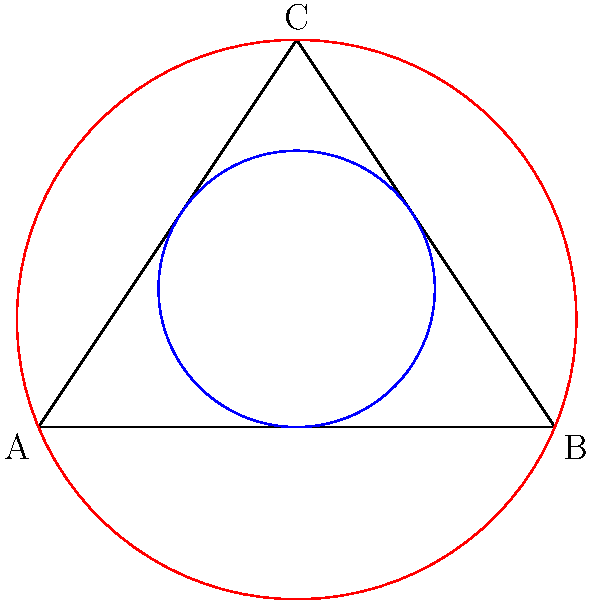In a mixed-gender sports competition, a triangular playing field is designed to represent balanced gender representation. The inscribed circle represents the core mixed-gender area, while the circumscribed circle represents the total field of play. If the radius of the inscribed circle is $r$ and the radius of the circumscribed circle is $R$, what is the ratio of $r$ to $R$ in terms of the semi-perimeter $s$ and the area $A$ of the triangle? To find the ratio of $r$ to $R$, we'll use the formulas for the radii of inscribed and circumscribed circles of a triangle:

1) For the inscribed circle: $r = \frac{A}{s}$, where $A$ is the area of the triangle and $s$ is the semi-perimeter.

2) For the circumscribed circle: $R = \frac{abc}{4A}$, where $a$, $b$, and $c$ are the side lengths of the triangle.

3) We can express $s$ in terms of $a$, $b$, and $c$: $s = \frac{a+b+c}{2}$

4) Now, let's set up the ratio:
   $\frac{r}{R} = \frac{A/s}{abc/(4A)}$

5) Simplify:
   $\frac{r}{R} = \frac{4A^2}{abcs}$

6) Recall that the area of a triangle can be expressed as $A = rs$ (area of a triangle = radius of inscribed circle * semi-perimeter)

7) Substitute $A = rs$ into our ratio:
   $\frac{r}{R} = \frac{4(rs)^2}{abcs} = \frac{4r^2s}{abc}$

8) Now, we have the ratio in terms of $r$, $s$, and the side lengths. To express it solely in terms of $s$ and $A$, we can use the formula for the area of a triangle: $A = \sqrt{s(s-a)(s-b)(s-c)}$

9) Square both sides: $A^2 = s(s-a)(s-b)(s-c)$

10) Divide both sides by $abc$: $\frac{A^2}{abc} = \frac{s(s-a)(s-b)(s-c)}{abc}$

11) The right side of this equation is equal to $\frac{r^2s}{abc}$ (from step 7)

12) Therefore, $\frac{r^2s}{abc} = \frac{A^2}{abc}$

13) Substitute this into our ratio from step 7:
    $\frac{r}{R} = \frac{4r^2s}{abc} = \frac{4A^2}{abc} = 4 \cdot \frac{A^2}{abc}$

Thus, we have derived the ratio of $r$ to $R$ in terms of $s$ and $A$.
Answer: $\frac{r}{R} = \frac{4A^2}{abcs}$ 